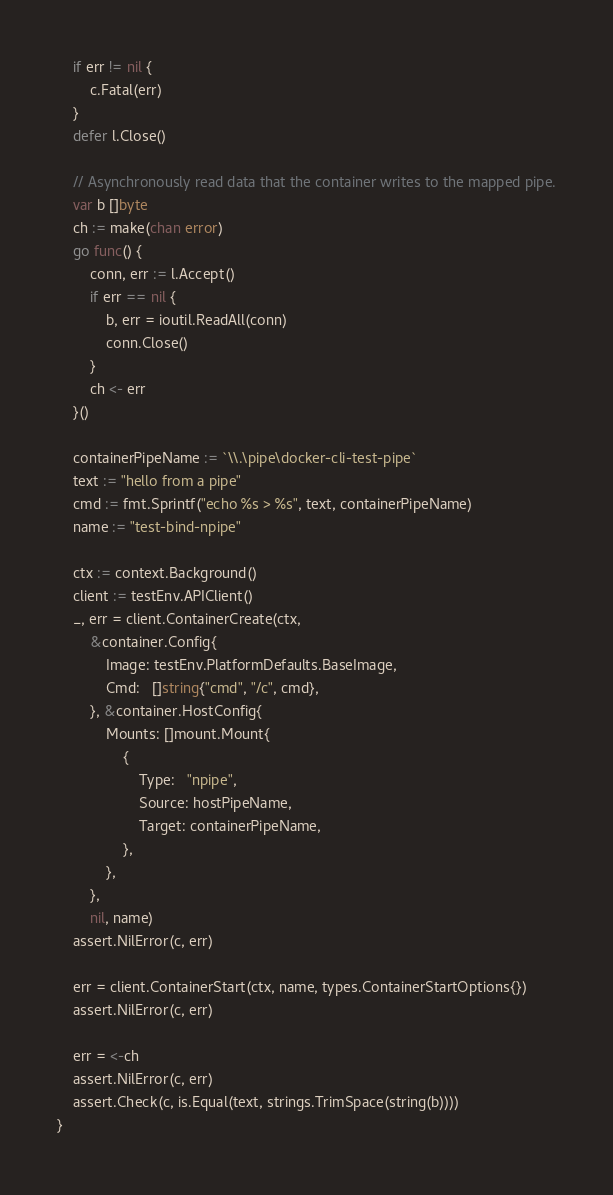<code> <loc_0><loc_0><loc_500><loc_500><_Go_>	if err != nil {
		c.Fatal(err)
	}
	defer l.Close()

	// Asynchronously read data that the container writes to the mapped pipe.
	var b []byte
	ch := make(chan error)
	go func() {
		conn, err := l.Accept()
		if err == nil {
			b, err = ioutil.ReadAll(conn)
			conn.Close()
		}
		ch <- err
	}()

	containerPipeName := `\\.\pipe\docker-cli-test-pipe`
	text := "hello from a pipe"
	cmd := fmt.Sprintf("echo %s > %s", text, containerPipeName)
	name := "test-bind-npipe"

	ctx := context.Background()
	client := testEnv.APIClient()
	_, err = client.ContainerCreate(ctx,
		&container.Config{
			Image: testEnv.PlatformDefaults.BaseImage,
			Cmd:   []string{"cmd", "/c", cmd},
		}, &container.HostConfig{
			Mounts: []mount.Mount{
				{
					Type:   "npipe",
					Source: hostPipeName,
					Target: containerPipeName,
				},
			},
		},
		nil, name)
	assert.NilError(c, err)

	err = client.ContainerStart(ctx, name, types.ContainerStartOptions{})
	assert.NilError(c, err)

	err = <-ch
	assert.NilError(c, err)
	assert.Check(c, is.Equal(text, strings.TrimSpace(string(b))))
}
</code> 